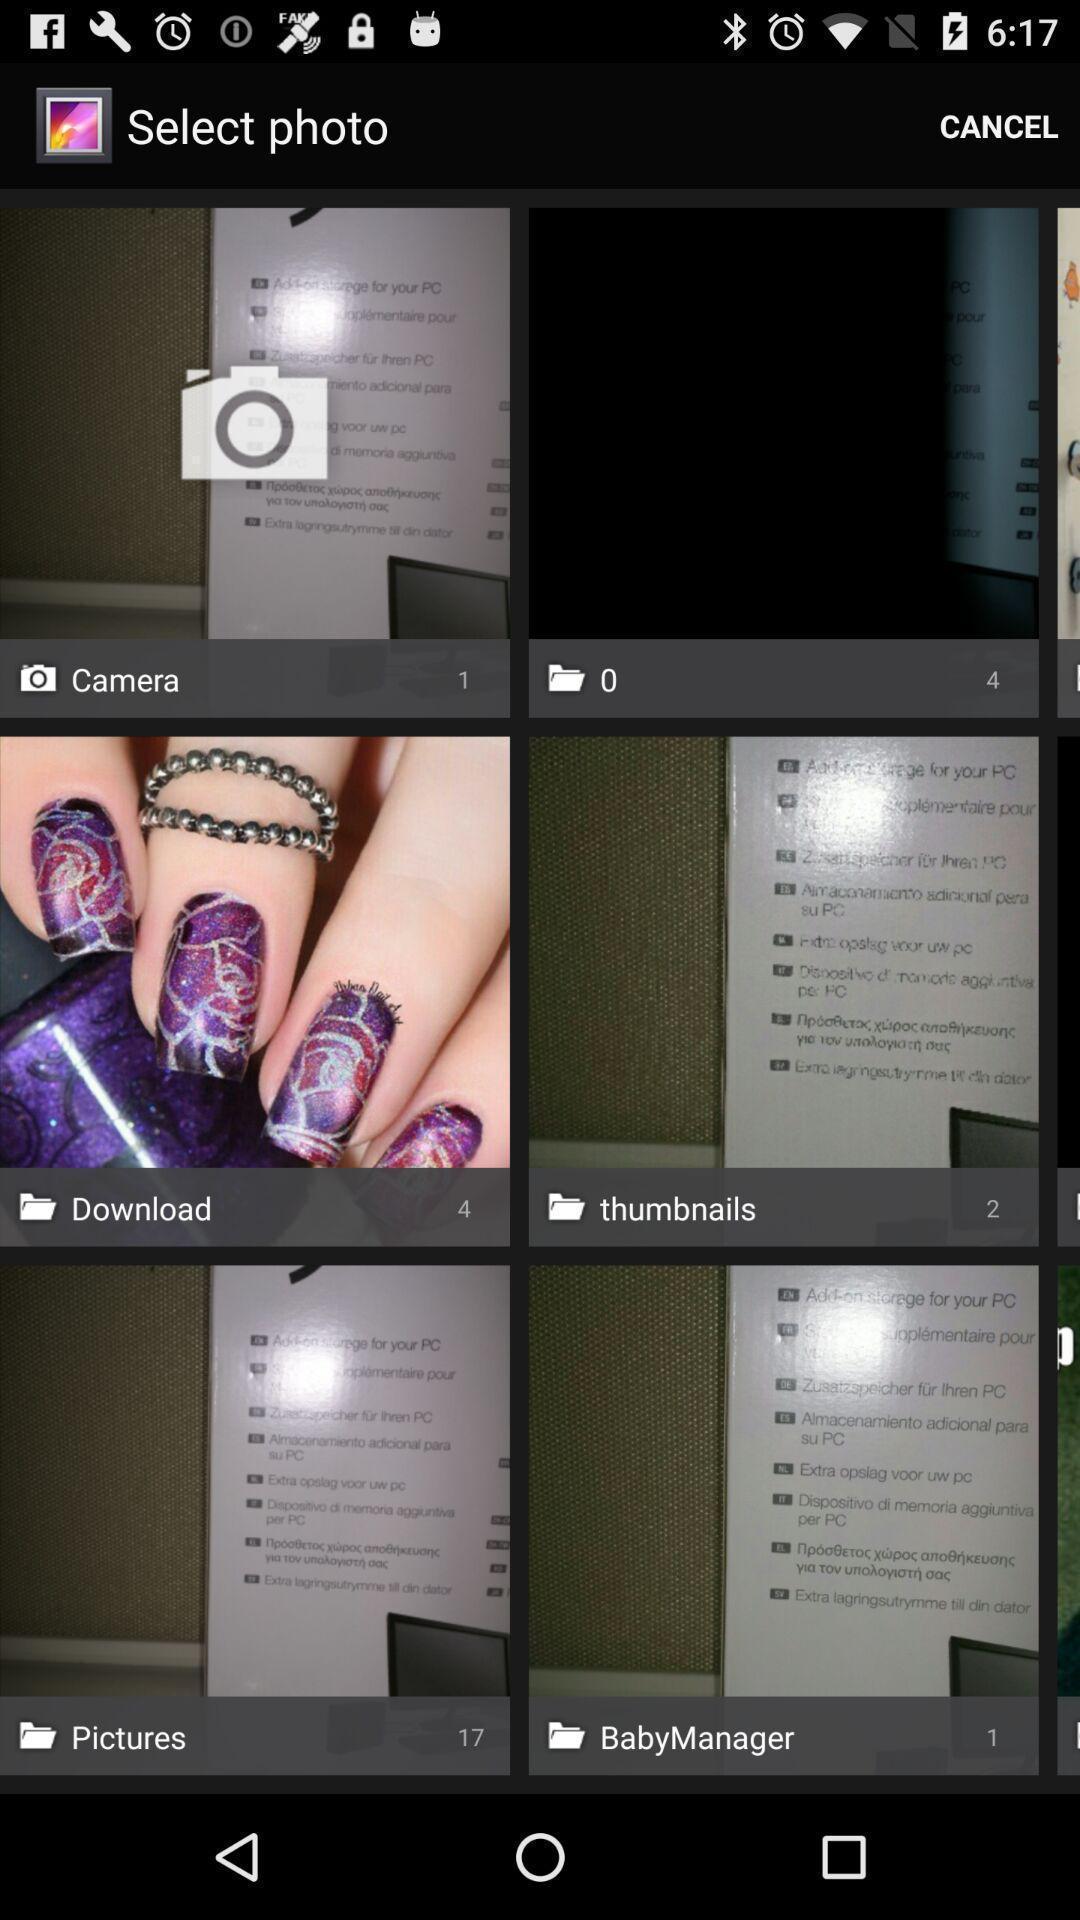Give me a summary of this screen capture. Page showing multiple options to select a photo. 